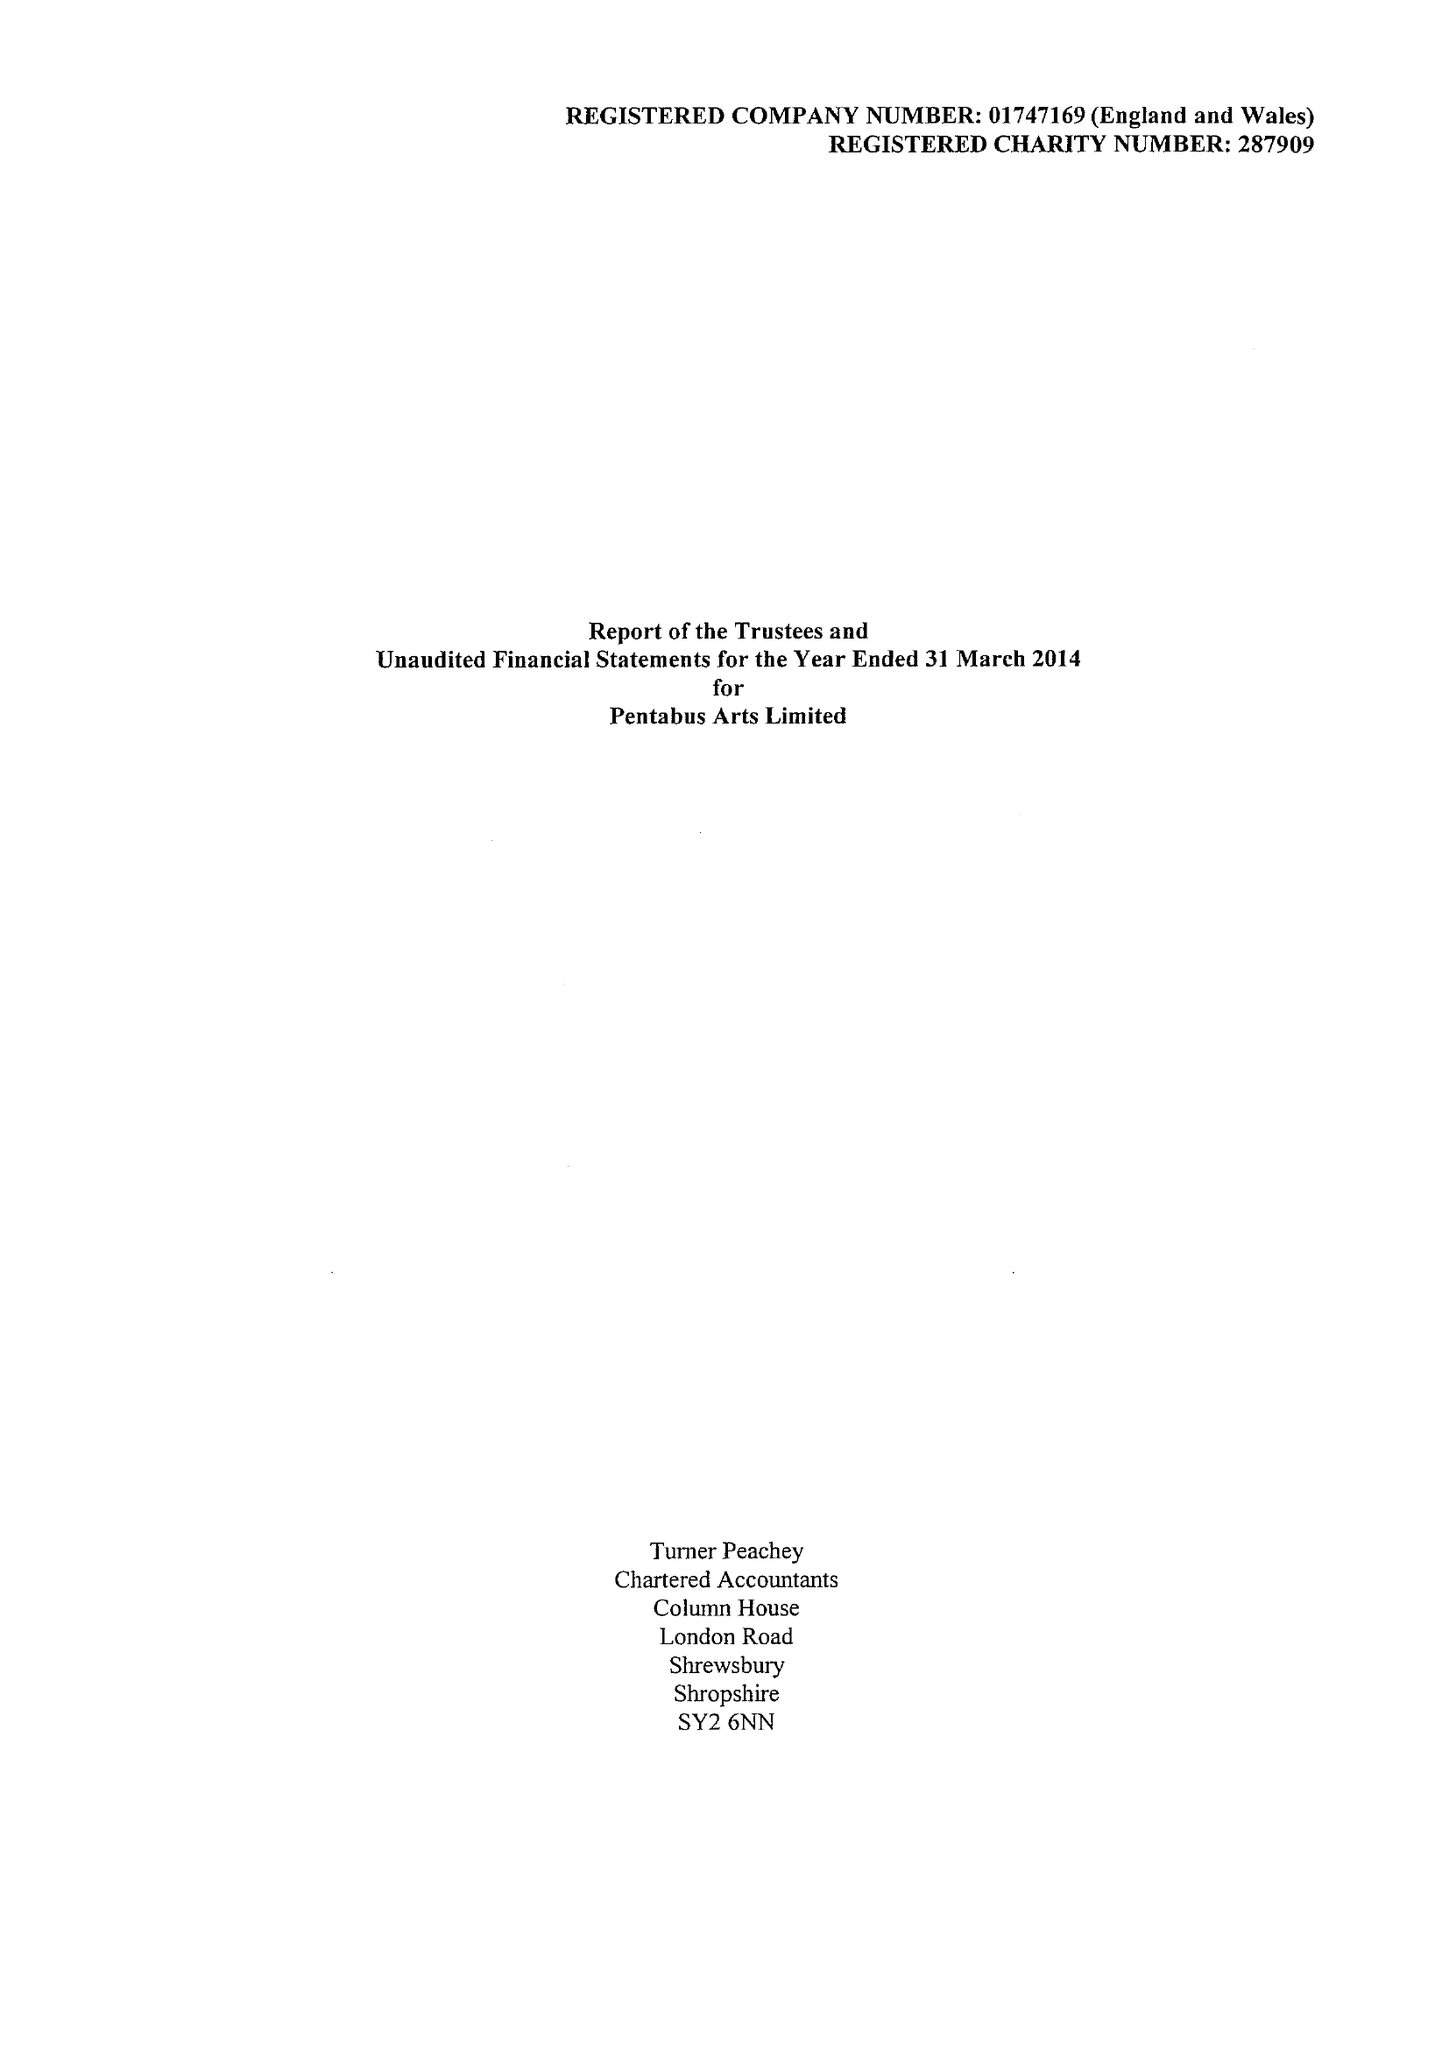What is the value for the address__post_town?
Answer the question using a single word or phrase. LUDLOW 